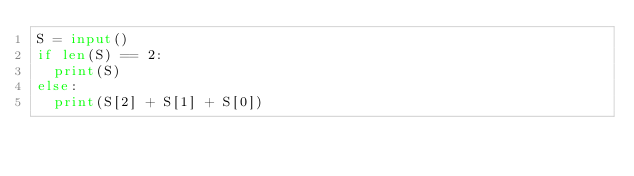<code> <loc_0><loc_0><loc_500><loc_500><_Python_>S = input()
if len(S) == 2:
  print(S)
else:
  print(S[2] + S[1] + S[0])</code> 